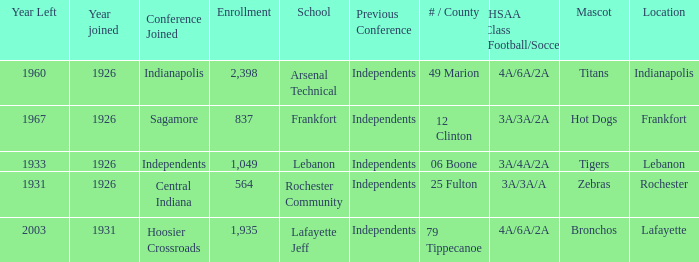What is the highest enrollment for rochester community school? 564.0. 